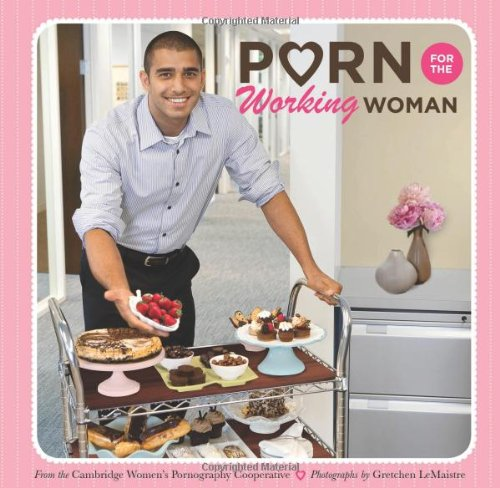Who is the author of this book? The book is published by the Cambridge Women's Pornography Cooperative, with contributions from Gretchen LeMaistre who is credited with the photographs. 